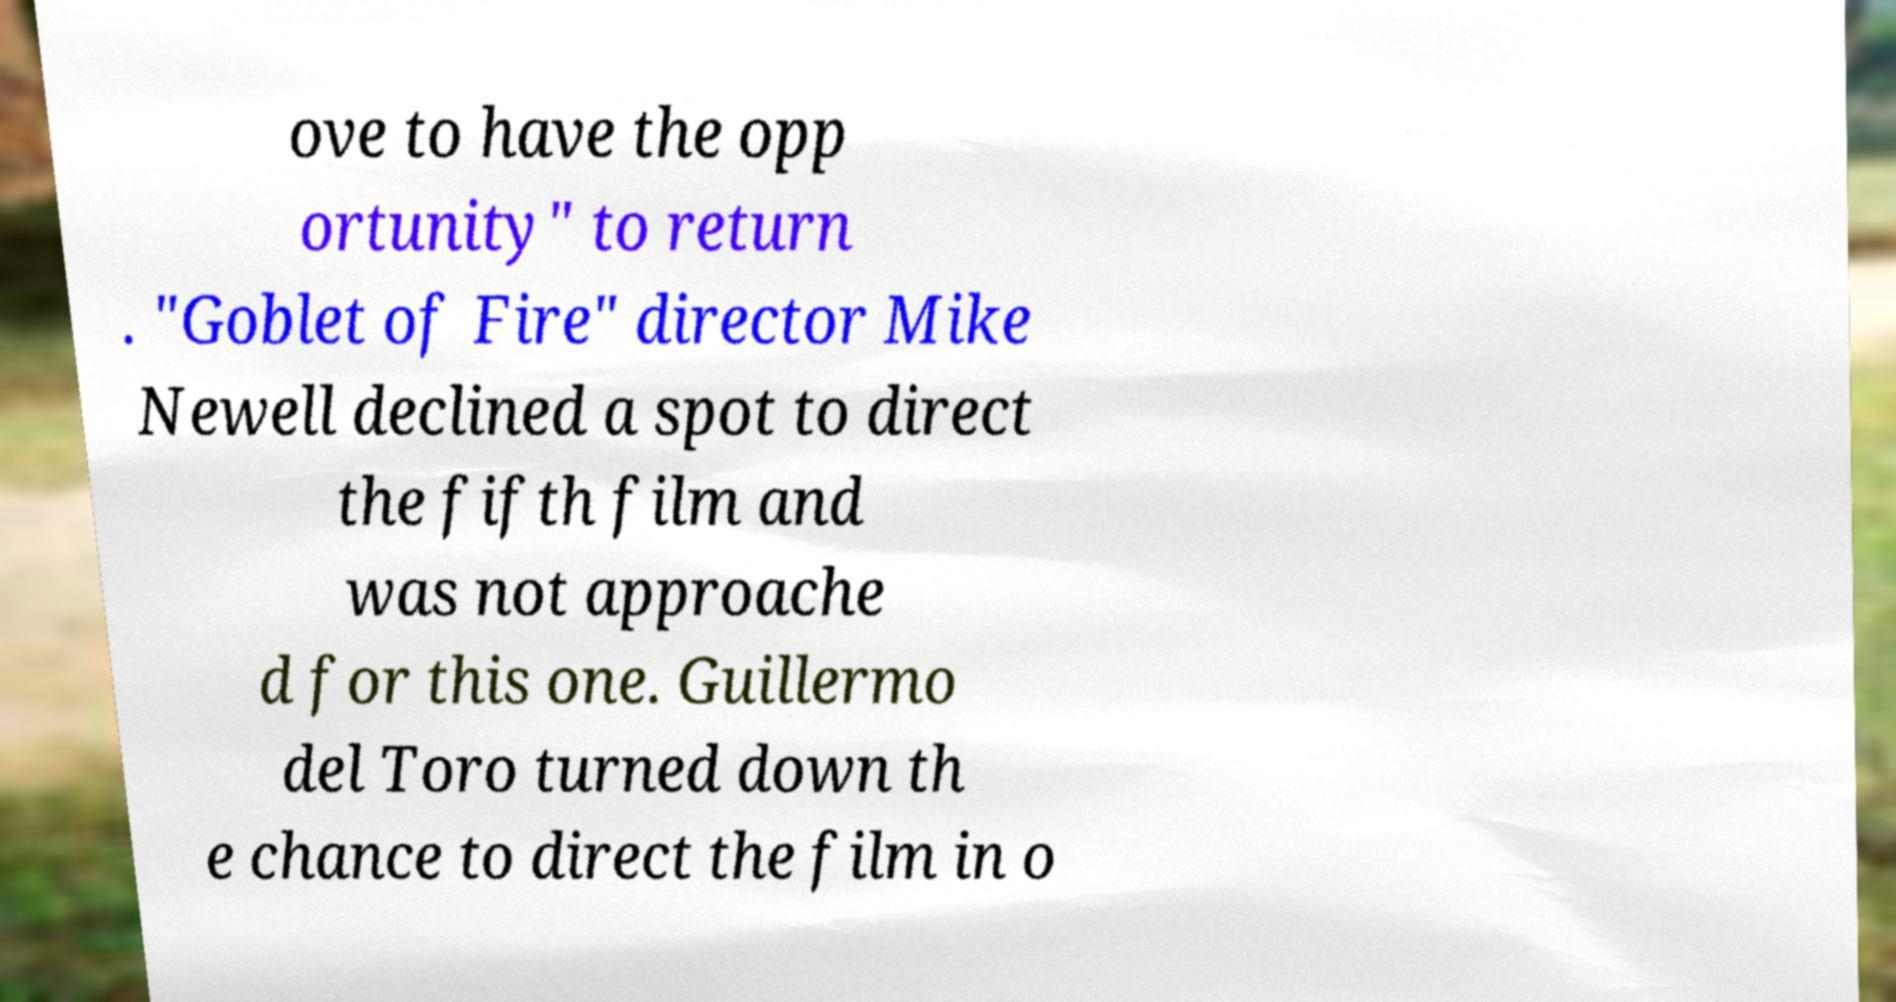Could you assist in decoding the text presented in this image and type it out clearly? ove to have the opp ortunity" to return . "Goblet of Fire" director Mike Newell declined a spot to direct the fifth film and was not approache d for this one. Guillermo del Toro turned down th e chance to direct the film in o 